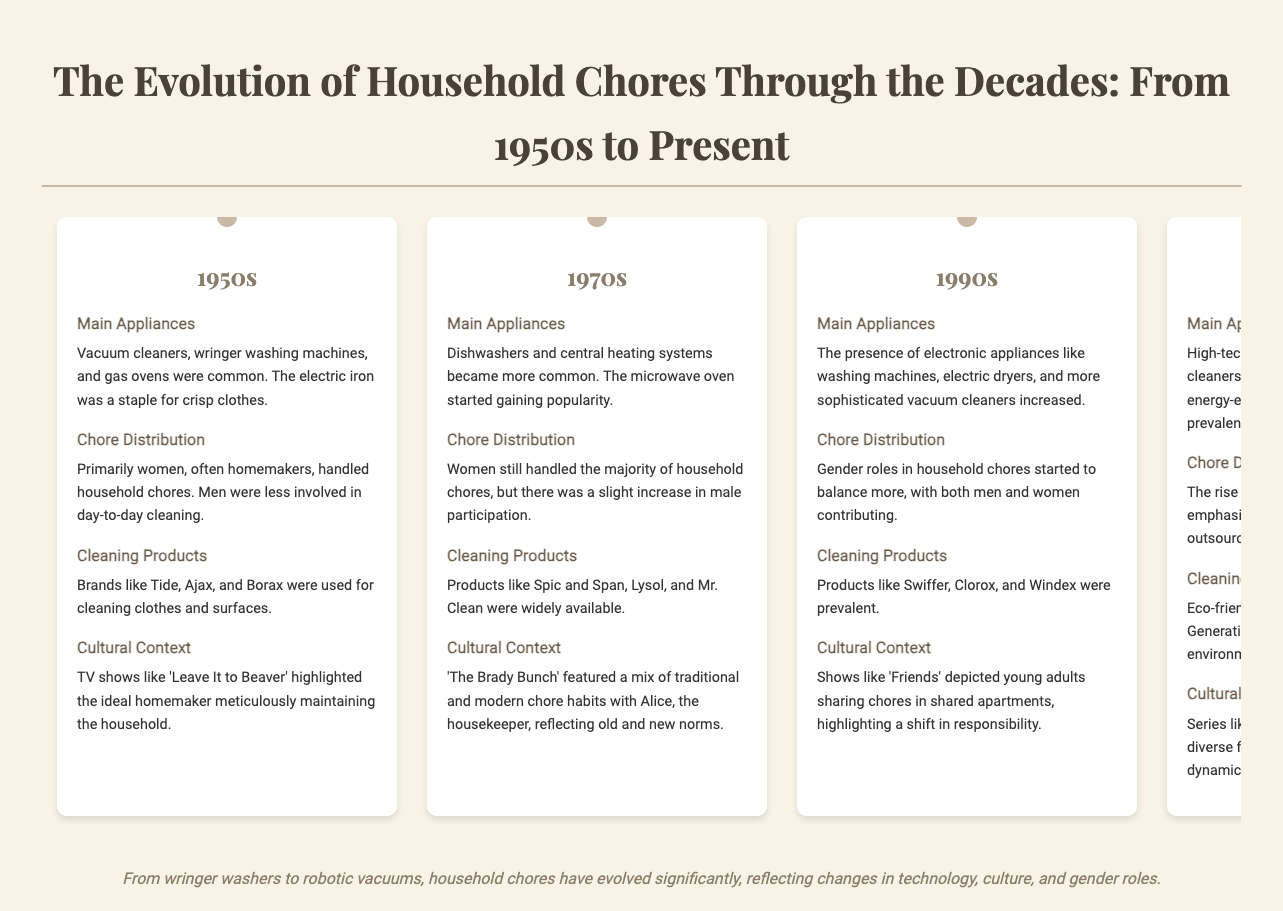What were common appliances in the 1950s? The 1950s featured vacuum cleaners, wringer washing machines, and gas ovens as common appliances.
Answer: vacuum cleaners, wringer washing machines, gas ovens Which television show highlighted the ideal homemaker in the 1950s? 'Leave It to Beaver' showcased the ideal homemaker in the 1950s.
Answer: Leave It to Beaver What cleaning products were used in the 1970s? In the 1970s, products like Spic and Span, Lysol, and Mr. Clean were widely available.
Answer: Spic and Span, Lysol, Mr. Clean What shift occurred in chore distribution by the 1990s? By the 1990s, gender roles in household chores started to balance more, with both men and women contributing.
Answer: Gender roles balanced Which decade saw the rise of eco-friendly cleaning products? The 2010s were notable for the popularity of eco-friendly brands like Method and Seventh Generation.
Answer: 2010s What cultural change was highlighted in the 2020s? The COVID-19 pandemic accentuated the importance of cleanliness and hygiene in daily routines.
Answer: COVID-19 pandemic What new technology became standard in the 2020s? Smart home technology, including smart refrigerators and advanced robotic cleaners, became standard in many households.
Answer: Smart home technology How did chore distribution change in the 2010s? The rise of dual-income families emphasized shared responsibilities and outsourcing chores to services.
Answer: Shared responsibilities What was a common appliance introduced in the 1970s? The microwave oven started gaining popularity during the 1970s.
Answer: Microwave oven 